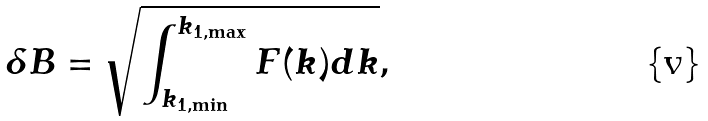<formula> <loc_0><loc_0><loc_500><loc_500>\delta B = \sqrt { \int ^ { k _ { 1 , \max } } _ { k _ { 1 , \min } } F ( k ) d k } ,</formula> 